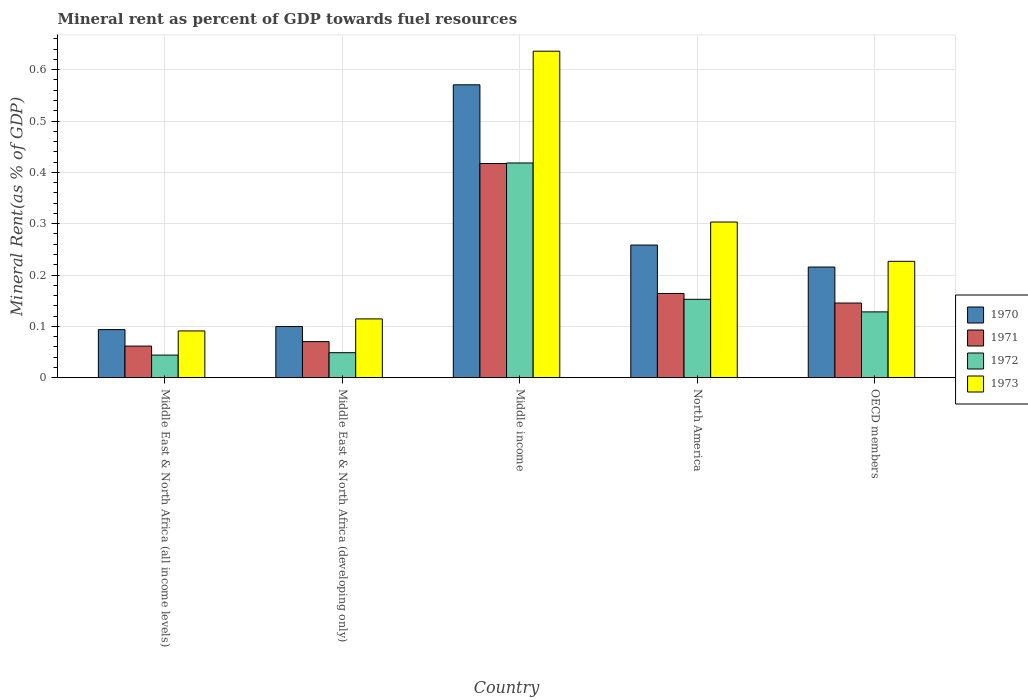How many different coloured bars are there?
Offer a terse response. 4. What is the label of the 3rd group of bars from the left?
Your answer should be compact. Middle income. What is the mineral rent in 1971 in OECD members?
Give a very brief answer. 0.15. Across all countries, what is the maximum mineral rent in 1972?
Offer a very short reply. 0.42. Across all countries, what is the minimum mineral rent in 1970?
Provide a short and direct response. 0.09. In which country was the mineral rent in 1971 maximum?
Offer a very short reply. Middle income. In which country was the mineral rent in 1973 minimum?
Your answer should be very brief. Middle East & North Africa (all income levels). What is the total mineral rent in 1972 in the graph?
Provide a succinct answer. 0.79. What is the difference between the mineral rent in 1971 in Middle East & North Africa (all income levels) and that in OECD members?
Your answer should be very brief. -0.08. What is the difference between the mineral rent in 1970 in Middle East & North Africa (developing only) and the mineral rent in 1972 in Middle East & North Africa (all income levels)?
Ensure brevity in your answer.  0.06. What is the average mineral rent in 1973 per country?
Provide a short and direct response. 0.27. What is the difference between the mineral rent of/in 1972 and mineral rent of/in 1970 in Middle East & North Africa (all income levels)?
Offer a very short reply. -0.05. What is the ratio of the mineral rent in 1973 in Middle East & North Africa (all income levels) to that in North America?
Keep it short and to the point. 0.3. Is the mineral rent in 1970 in Middle East & North Africa (developing only) less than that in OECD members?
Your answer should be very brief. Yes. What is the difference between the highest and the second highest mineral rent in 1970?
Offer a very short reply. 0.36. What is the difference between the highest and the lowest mineral rent in 1972?
Provide a short and direct response. 0.37. Is the sum of the mineral rent in 1971 in Middle income and North America greater than the maximum mineral rent in 1972 across all countries?
Your answer should be compact. Yes. What does the 4th bar from the left in OECD members represents?
Make the answer very short. 1973. What does the 3rd bar from the right in Middle East & North Africa (all income levels) represents?
Your answer should be very brief. 1971. How many bars are there?
Provide a succinct answer. 20. Are the values on the major ticks of Y-axis written in scientific E-notation?
Your response must be concise. No. Does the graph contain grids?
Offer a terse response. Yes. Where does the legend appear in the graph?
Give a very brief answer. Center right. How many legend labels are there?
Provide a succinct answer. 4. How are the legend labels stacked?
Ensure brevity in your answer.  Vertical. What is the title of the graph?
Provide a succinct answer. Mineral rent as percent of GDP towards fuel resources. What is the label or title of the Y-axis?
Provide a short and direct response. Mineral Rent(as % of GDP). What is the Mineral Rent(as % of GDP) in 1970 in Middle East & North Africa (all income levels)?
Offer a terse response. 0.09. What is the Mineral Rent(as % of GDP) of 1971 in Middle East & North Africa (all income levels)?
Your response must be concise. 0.06. What is the Mineral Rent(as % of GDP) in 1972 in Middle East & North Africa (all income levels)?
Your answer should be compact. 0.04. What is the Mineral Rent(as % of GDP) in 1973 in Middle East & North Africa (all income levels)?
Give a very brief answer. 0.09. What is the Mineral Rent(as % of GDP) of 1970 in Middle East & North Africa (developing only)?
Your answer should be very brief. 0.1. What is the Mineral Rent(as % of GDP) in 1971 in Middle East & North Africa (developing only)?
Your answer should be compact. 0.07. What is the Mineral Rent(as % of GDP) of 1972 in Middle East & North Africa (developing only)?
Offer a very short reply. 0.05. What is the Mineral Rent(as % of GDP) of 1973 in Middle East & North Africa (developing only)?
Provide a succinct answer. 0.11. What is the Mineral Rent(as % of GDP) in 1970 in Middle income?
Your answer should be compact. 0.57. What is the Mineral Rent(as % of GDP) of 1971 in Middle income?
Provide a short and direct response. 0.42. What is the Mineral Rent(as % of GDP) of 1972 in Middle income?
Offer a terse response. 0.42. What is the Mineral Rent(as % of GDP) of 1973 in Middle income?
Your answer should be very brief. 0.64. What is the Mineral Rent(as % of GDP) in 1970 in North America?
Offer a very short reply. 0.26. What is the Mineral Rent(as % of GDP) of 1971 in North America?
Offer a terse response. 0.16. What is the Mineral Rent(as % of GDP) of 1972 in North America?
Make the answer very short. 0.15. What is the Mineral Rent(as % of GDP) of 1973 in North America?
Offer a terse response. 0.3. What is the Mineral Rent(as % of GDP) in 1970 in OECD members?
Offer a very short reply. 0.22. What is the Mineral Rent(as % of GDP) of 1971 in OECD members?
Your response must be concise. 0.15. What is the Mineral Rent(as % of GDP) in 1972 in OECD members?
Offer a very short reply. 0.13. What is the Mineral Rent(as % of GDP) of 1973 in OECD members?
Ensure brevity in your answer.  0.23. Across all countries, what is the maximum Mineral Rent(as % of GDP) in 1970?
Your answer should be very brief. 0.57. Across all countries, what is the maximum Mineral Rent(as % of GDP) in 1971?
Your answer should be compact. 0.42. Across all countries, what is the maximum Mineral Rent(as % of GDP) in 1972?
Your response must be concise. 0.42. Across all countries, what is the maximum Mineral Rent(as % of GDP) in 1973?
Provide a succinct answer. 0.64. Across all countries, what is the minimum Mineral Rent(as % of GDP) in 1970?
Your response must be concise. 0.09. Across all countries, what is the minimum Mineral Rent(as % of GDP) in 1971?
Provide a short and direct response. 0.06. Across all countries, what is the minimum Mineral Rent(as % of GDP) in 1972?
Ensure brevity in your answer.  0.04. Across all countries, what is the minimum Mineral Rent(as % of GDP) of 1973?
Your answer should be compact. 0.09. What is the total Mineral Rent(as % of GDP) of 1970 in the graph?
Ensure brevity in your answer.  1.24. What is the total Mineral Rent(as % of GDP) of 1971 in the graph?
Your answer should be compact. 0.86. What is the total Mineral Rent(as % of GDP) of 1972 in the graph?
Offer a terse response. 0.79. What is the total Mineral Rent(as % of GDP) in 1973 in the graph?
Keep it short and to the point. 1.37. What is the difference between the Mineral Rent(as % of GDP) of 1970 in Middle East & North Africa (all income levels) and that in Middle East & North Africa (developing only)?
Make the answer very short. -0.01. What is the difference between the Mineral Rent(as % of GDP) of 1971 in Middle East & North Africa (all income levels) and that in Middle East & North Africa (developing only)?
Provide a short and direct response. -0.01. What is the difference between the Mineral Rent(as % of GDP) of 1972 in Middle East & North Africa (all income levels) and that in Middle East & North Africa (developing only)?
Offer a terse response. -0. What is the difference between the Mineral Rent(as % of GDP) of 1973 in Middle East & North Africa (all income levels) and that in Middle East & North Africa (developing only)?
Ensure brevity in your answer.  -0.02. What is the difference between the Mineral Rent(as % of GDP) of 1970 in Middle East & North Africa (all income levels) and that in Middle income?
Ensure brevity in your answer.  -0.48. What is the difference between the Mineral Rent(as % of GDP) in 1971 in Middle East & North Africa (all income levels) and that in Middle income?
Provide a short and direct response. -0.36. What is the difference between the Mineral Rent(as % of GDP) in 1972 in Middle East & North Africa (all income levels) and that in Middle income?
Your answer should be compact. -0.37. What is the difference between the Mineral Rent(as % of GDP) of 1973 in Middle East & North Africa (all income levels) and that in Middle income?
Make the answer very short. -0.55. What is the difference between the Mineral Rent(as % of GDP) in 1970 in Middle East & North Africa (all income levels) and that in North America?
Ensure brevity in your answer.  -0.16. What is the difference between the Mineral Rent(as % of GDP) of 1971 in Middle East & North Africa (all income levels) and that in North America?
Make the answer very short. -0.1. What is the difference between the Mineral Rent(as % of GDP) of 1972 in Middle East & North Africa (all income levels) and that in North America?
Offer a very short reply. -0.11. What is the difference between the Mineral Rent(as % of GDP) of 1973 in Middle East & North Africa (all income levels) and that in North America?
Offer a terse response. -0.21. What is the difference between the Mineral Rent(as % of GDP) of 1970 in Middle East & North Africa (all income levels) and that in OECD members?
Provide a short and direct response. -0.12. What is the difference between the Mineral Rent(as % of GDP) in 1971 in Middle East & North Africa (all income levels) and that in OECD members?
Offer a very short reply. -0.08. What is the difference between the Mineral Rent(as % of GDP) of 1972 in Middle East & North Africa (all income levels) and that in OECD members?
Your response must be concise. -0.08. What is the difference between the Mineral Rent(as % of GDP) in 1973 in Middle East & North Africa (all income levels) and that in OECD members?
Your response must be concise. -0.14. What is the difference between the Mineral Rent(as % of GDP) in 1970 in Middle East & North Africa (developing only) and that in Middle income?
Provide a succinct answer. -0.47. What is the difference between the Mineral Rent(as % of GDP) in 1971 in Middle East & North Africa (developing only) and that in Middle income?
Offer a terse response. -0.35. What is the difference between the Mineral Rent(as % of GDP) of 1972 in Middle East & North Africa (developing only) and that in Middle income?
Provide a succinct answer. -0.37. What is the difference between the Mineral Rent(as % of GDP) in 1973 in Middle East & North Africa (developing only) and that in Middle income?
Provide a short and direct response. -0.52. What is the difference between the Mineral Rent(as % of GDP) of 1970 in Middle East & North Africa (developing only) and that in North America?
Offer a very short reply. -0.16. What is the difference between the Mineral Rent(as % of GDP) in 1971 in Middle East & North Africa (developing only) and that in North America?
Provide a short and direct response. -0.09. What is the difference between the Mineral Rent(as % of GDP) in 1972 in Middle East & North Africa (developing only) and that in North America?
Give a very brief answer. -0.1. What is the difference between the Mineral Rent(as % of GDP) in 1973 in Middle East & North Africa (developing only) and that in North America?
Your response must be concise. -0.19. What is the difference between the Mineral Rent(as % of GDP) of 1970 in Middle East & North Africa (developing only) and that in OECD members?
Your answer should be compact. -0.12. What is the difference between the Mineral Rent(as % of GDP) in 1971 in Middle East & North Africa (developing only) and that in OECD members?
Provide a succinct answer. -0.08. What is the difference between the Mineral Rent(as % of GDP) in 1972 in Middle East & North Africa (developing only) and that in OECD members?
Your answer should be very brief. -0.08. What is the difference between the Mineral Rent(as % of GDP) of 1973 in Middle East & North Africa (developing only) and that in OECD members?
Offer a terse response. -0.11. What is the difference between the Mineral Rent(as % of GDP) in 1970 in Middle income and that in North America?
Offer a terse response. 0.31. What is the difference between the Mineral Rent(as % of GDP) in 1971 in Middle income and that in North America?
Provide a short and direct response. 0.25. What is the difference between the Mineral Rent(as % of GDP) of 1972 in Middle income and that in North America?
Your response must be concise. 0.27. What is the difference between the Mineral Rent(as % of GDP) of 1973 in Middle income and that in North America?
Offer a very short reply. 0.33. What is the difference between the Mineral Rent(as % of GDP) in 1970 in Middle income and that in OECD members?
Your answer should be compact. 0.35. What is the difference between the Mineral Rent(as % of GDP) in 1971 in Middle income and that in OECD members?
Offer a very short reply. 0.27. What is the difference between the Mineral Rent(as % of GDP) of 1972 in Middle income and that in OECD members?
Offer a terse response. 0.29. What is the difference between the Mineral Rent(as % of GDP) in 1973 in Middle income and that in OECD members?
Make the answer very short. 0.41. What is the difference between the Mineral Rent(as % of GDP) of 1970 in North America and that in OECD members?
Keep it short and to the point. 0.04. What is the difference between the Mineral Rent(as % of GDP) of 1971 in North America and that in OECD members?
Your answer should be very brief. 0.02. What is the difference between the Mineral Rent(as % of GDP) in 1972 in North America and that in OECD members?
Ensure brevity in your answer.  0.02. What is the difference between the Mineral Rent(as % of GDP) in 1973 in North America and that in OECD members?
Keep it short and to the point. 0.08. What is the difference between the Mineral Rent(as % of GDP) in 1970 in Middle East & North Africa (all income levels) and the Mineral Rent(as % of GDP) in 1971 in Middle East & North Africa (developing only)?
Ensure brevity in your answer.  0.02. What is the difference between the Mineral Rent(as % of GDP) of 1970 in Middle East & North Africa (all income levels) and the Mineral Rent(as % of GDP) of 1972 in Middle East & North Africa (developing only)?
Provide a succinct answer. 0.04. What is the difference between the Mineral Rent(as % of GDP) in 1970 in Middle East & North Africa (all income levels) and the Mineral Rent(as % of GDP) in 1973 in Middle East & North Africa (developing only)?
Provide a short and direct response. -0.02. What is the difference between the Mineral Rent(as % of GDP) in 1971 in Middle East & North Africa (all income levels) and the Mineral Rent(as % of GDP) in 1972 in Middle East & North Africa (developing only)?
Keep it short and to the point. 0.01. What is the difference between the Mineral Rent(as % of GDP) of 1971 in Middle East & North Africa (all income levels) and the Mineral Rent(as % of GDP) of 1973 in Middle East & North Africa (developing only)?
Provide a short and direct response. -0.05. What is the difference between the Mineral Rent(as % of GDP) of 1972 in Middle East & North Africa (all income levels) and the Mineral Rent(as % of GDP) of 1973 in Middle East & North Africa (developing only)?
Ensure brevity in your answer.  -0.07. What is the difference between the Mineral Rent(as % of GDP) of 1970 in Middle East & North Africa (all income levels) and the Mineral Rent(as % of GDP) of 1971 in Middle income?
Provide a short and direct response. -0.32. What is the difference between the Mineral Rent(as % of GDP) in 1970 in Middle East & North Africa (all income levels) and the Mineral Rent(as % of GDP) in 1972 in Middle income?
Make the answer very short. -0.32. What is the difference between the Mineral Rent(as % of GDP) in 1970 in Middle East & North Africa (all income levels) and the Mineral Rent(as % of GDP) in 1973 in Middle income?
Give a very brief answer. -0.54. What is the difference between the Mineral Rent(as % of GDP) in 1971 in Middle East & North Africa (all income levels) and the Mineral Rent(as % of GDP) in 1972 in Middle income?
Your answer should be compact. -0.36. What is the difference between the Mineral Rent(as % of GDP) of 1971 in Middle East & North Africa (all income levels) and the Mineral Rent(as % of GDP) of 1973 in Middle income?
Provide a short and direct response. -0.57. What is the difference between the Mineral Rent(as % of GDP) of 1972 in Middle East & North Africa (all income levels) and the Mineral Rent(as % of GDP) of 1973 in Middle income?
Provide a succinct answer. -0.59. What is the difference between the Mineral Rent(as % of GDP) of 1970 in Middle East & North Africa (all income levels) and the Mineral Rent(as % of GDP) of 1971 in North America?
Offer a terse response. -0.07. What is the difference between the Mineral Rent(as % of GDP) of 1970 in Middle East & North Africa (all income levels) and the Mineral Rent(as % of GDP) of 1972 in North America?
Your response must be concise. -0.06. What is the difference between the Mineral Rent(as % of GDP) in 1970 in Middle East & North Africa (all income levels) and the Mineral Rent(as % of GDP) in 1973 in North America?
Your response must be concise. -0.21. What is the difference between the Mineral Rent(as % of GDP) of 1971 in Middle East & North Africa (all income levels) and the Mineral Rent(as % of GDP) of 1972 in North America?
Keep it short and to the point. -0.09. What is the difference between the Mineral Rent(as % of GDP) in 1971 in Middle East & North Africa (all income levels) and the Mineral Rent(as % of GDP) in 1973 in North America?
Provide a short and direct response. -0.24. What is the difference between the Mineral Rent(as % of GDP) of 1972 in Middle East & North Africa (all income levels) and the Mineral Rent(as % of GDP) of 1973 in North America?
Provide a succinct answer. -0.26. What is the difference between the Mineral Rent(as % of GDP) of 1970 in Middle East & North Africa (all income levels) and the Mineral Rent(as % of GDP) of 1971 in OECD members?
Give a very brief answer. -0.05. What is the difference between the Mineral Rent(as % of GDP) in 1970 in Middle East & North Africa (all income levels) and the Mineral Rent(as % of GDP) in 1972 in OECD members?
Your answer should be very brief. -0.03. What is the difference between the Mineral Rent(as % of GDP) in 1970 in Middle East & North Africa (all income levels) and the Mineral Rent(as % of GDP) in 1973 in OECD members?
Make the answer very short. -0.13. What is the difference between the Mineral Rent(as % of GDP) of 1971 in Middle East & North Africa (all income levels) and the Mineral Rent(as % of GDP) of 1972 in OECD members?
Your answer should be very brief. -0.07. What is the difference between the Mineral Rent(as % of GDP) of 1971 in Middle East & North Africa (all income levels) and the Mineral Rent(as % of GDP) of 1973 in OECD members?
Ensure brevity in your answer.  -0.17. What is the difference between the Mineral Rent(as % of GDP) of 1972 in Middle East & North Africa (all income levels) and the Mineral Rent(as % of GDP) of 1973 in OECD members?
Offer a terse response. -0.18. What is the difference between the Mineral Rent(as % of GDP) of 1970 in Middle East & North Africa (developing only) and the Mineral Rent(as % of GDP) of 1971 in Middle income?
Provide a succinct answer. -0.32. What is the difference between the Mineral Rent(as % of GDP) of 1970 in Middle East & North Africa (developing only) and the Mineral Rent(as % of GDP) of 1972 in Middle income?
Offer a terse response. -0.32. What is the difference between the Mineral Rent(as % of GDP) in 1970 in Middle East & North Africa (developing only) and the Mineral Rent(as % of GDP) in 1973 in Middle income?
Make the answer very short. -0.54. What is the difference between the Mineral Rent(as % of GDP) of 1971 in Middle East & North Africa (developing only) and the Mineral Rent(as % of GDP) of 1972 in Middle income?
Make the answer very short. -0.35. What is the difference between the Mineral Rent(as % of GDP) in 1971 in Middle East & North Africa (developing only) and the Mineral Rent(as % of GDP) in 1973 in Middle income?
Ensure brevity in your answer.  -0.57. What is the difference between the Mineral Rent(as % of GDP) in 1972 in Middle East & North Africa (developing only) and the Mineral Rent(as % of GDP) in 1973 in Middle income?
Provide a succinct answer. -0.59. What is the difference between the Mineral Rent(as % of GDP) in 1970 in Middle East & North Africa (developing only) and the Mineral Rent(as % of GDP) in 1971 in North America?
Provide a succinct answer. -0.06. What is the difference between the Mineral Rent(as % of GDP) of 1970 in Middle East & North Africa (developing only) and the Mineral Rent(as % of GDP) of 1972 in North America?
Your answer should be compact. -0.05. What is the difference between the Mineral Rent(as % of GDP) in 1970 in Middle East & North Africa (developing only) and the Mineral Rent(as % of GDP) in 1973 in North America?
Provide a short and direct response. -0.2. What is the difference between the Mineral Rent(as % of GDP) in 1971 in Middle East & North Africa (developing only) and the Mineral Rent(as % of GDP) in 1972 in North America?
Offer a terse response. -0.08. What is the difference between the Mineral Rent(as % of GDP) of 1971 in Middle East & North Africa (developing only) and the Mineral Rent(as % of GDP) of 1973 in North America?
Offer a terse response. -0.23. What is the difference between the Mineral Rent(as % of GDP) in 1972 in Middle East & North Africa (developing only) and the Mineral Rent(as % of GDP) in 1973 in North America?
Offer a terse response. -0.25. What is the difference between the Mineral Rent(as % of GDP) in 1970 in Middle East & North Africa (developing only) and the Mineral Rent(as % of GDP) in 1971 in OECD members?
Provide a succinct answer. -0.05. What is the difference between the Mineral Rent(as % of GDP) in 1970 in Middle East & North Africa (developing only) and the Mineral Rent(as % of GDP) in 1972 in OECD members?
Give a very brief answer. -0.03. What is the difference between the Mineral Rent(as % of GDP) in 1970 in Middle East & North Africa (developing only) and the Mineral Rent(as % of GDP) in 1973 in OECD members?
Your answer should be compact. -0.13. What is the difference between the Mineral Rent(as % of GDP) of 1971 in Middle East & North Africa (developing only) and the Mineral Rent(as % of GDP) of 1972 in OECD members?
Keep it short and to the point. -0.06. What is the difference between the Mineral Rent(as % of GDP) in 1971 in Middle East & North Africa (developing only) and the Mineral Rent(as % of GDP) in 1973 in OECD members?
Keep it short and to the point. -0.16. What is the difference between the Mineral Rent(as % of GDP) of 1972 in Middle East & North Africa (developing only) and the Mineral Rent(as % of GDP) of 1973 in OECD members?
Keep it short and to the point. -0.18. What is the difference between the Mineral Rent(as % of GDP) in 1970 in Middle income and the Mineral Rent(as % of GDP) in 1971 in North America?
Give a very brief answer. 0.41. What is the difference between the Mineral Rent(as % of GDP) of 1970 in Middle income and the Mineral Rent(as % of GDP) of 1972 in North America?
Offer a terse response. 0.42. What is the difference between the Mineral Rent(as % of GDP) of 1970 in Middle income and the Mineral Rent(as % of GDP) of 1973 in North America?
Your answer should be very brief. 0.27. What is the difference between the Mineral Rent(as % of GDP) in 1971 in Middle income and the Mineral Rent(as % of GDP) in 1972 in North America?
Ensure brevity in your answer.  0.26. What is the difference between the Mineral Rent(as % of GDP) in 1971 in Middle income and the Mineral Rent(as % of GDP) in 1973 in North America?
Keep it short and to the point. 0.11. What is the difference between the Mineral Rent(as % of GDP) in 1972 in Middle income and the Mineral Rent(as % of GDP) in 1973 in North America?
Your response must be concise. 0.12. What is the difference between the Mineral Rent(as % of GDP) of 1970 in Middle income and the Mineral Rent(as % of GDP) of 1971 in OECD members?
Your response must be concise. 0.43. What is the difference between the Mineral Rent(as % of GDP) in 1970 in Middle income and the Mineral Rent(as % of GDP) in 1972 in OECD members?
Your answer should be compact. 0.44. What is the difference between the Mineral Rent(as % of GDP) in 1970 in Middle income and the Mineral Rent(as % of GDP) in 1973 in OECD members?
Keep it short and to the point. 0.34. What is the difference between the Mineral Rent(as % of GDP) in 1971 in Middle income and the Mineral Rent(as % of GDP) in 1972 in OECD members?
Your response must be concise. 0.29. What is the difference between the Mineral Rent(as % of GDP) in 1971 in Middle income and the Mineral Rent(as % of GDP) in 1973 in OECD members?
Provide a succinct answer. 0.19. What is the difference between the Mineral Rent(as % of GDP) in 1972 in Middle income and the Mineral Rent(as % of GDP) in 1973 in OECD members?
Provide a succinct answer. 0.19. What is the difference between the Mineral Rent(as % of GDP) in 1970 in North America and the Mineral Rent(as % of GDP) in 1971 in OECD members?
Offer a terse response. 0.11. What is the difference between the Mineral Rent(as % of GDP) in 1970 in North America and the Mineral Rent(as % of GDP) in 1972 in OECD members?
Offer a very short reply. 0.13. What is the difference between the Mineral Rent(as % of GDP) in 1970 in North America and the Mineral Rent(as % of GDP) in 1973 in OECD members?
Offer a very short reply. 0.03. What is the difference between the Mineral Rent(as % of GDP) in 1971 in North America and the Mineral Rent(as % of GDP) in 1972 in OECD members?
Offer a terse response. 0.04. What is the difference between the Mineral Rent(as % of GDP) in 1971 in North America and the Mineral Rent(as % of GDP) in 1973 in OECD members?
Your answer should be very brief. -0.06. What is the difference between the Mineral Rent(as % of GDP) in 1972 in North America and the Mineral Rent(as % of GDP) in 1973 in OECD members?
Make the answer very short. -0.07. What is the average Mineral Rent(as % of GDP) of 1970 per country?
Your answer should be compact. 0.25. What is the average Mineral Rent(as % of GDP) in 1971 per country?
Offer a terse response. 0.17. What is the average Mineral Rent(as % of GDP) of 1972 per country?
Your response must be concise. 0.16. What is the average Mineral Rent(as % of GDP) in 1973 per country?
Keep it short and to the point. 0.27. What is the difference between the Mineral Rent(as % of GDP) of 1970 and Mineral Rent(as % of GDP) of 1971 in Middle East & North Africa (all income levels)?
Offer a terse response. 0.03. What is the difference between the Mineral Rent(as % of GDP) of 1970 and Mineral Rent(as % of GDP) of 1972 in Middle East & North Africa (all income levels)?
Provide a short and direct response. 0.05. What is the difference between the Mineral Rent(as % of GDP) in 1970 and Mineral Rent(as % of GDP) in 1973 in Middle East & North Africa (all income levels)?
Provide a succinct answer. 0. What is the difference between the Mineral Rent(as % of GDP) of 1971 and Mineral Rent(as % of GDP) of 1972 in Middle East & North Africa (all income levels)?
Make the answer very short. 0.02. What is the difference between the Mineral Rent(as % of GDP) of 1971 and Mineral Rent(as % of GDP) of 1973 in Middle East & North Africa (all income levels)?
Give a very brief answer. -0.03. What is the difference between the Mineral Rent(as % of GDP) of 1972 and Mineral Rent(as % of GDP) of 1973 in Middle East & North Africa (all income levels)?
Your answer should be compact. -0.05. What is the difference between the Mineral Rent(as % of GDP) of 1970 and Mineral Rent(as % of GDP) of 1971 in Middle East & North Africa (developing only)?
Ensure brevity in your answer.  0.03. What is the difference between the Mineral Rent(as % of GDP) of 1970 and Mineral Rent(as % of GDP) of 1972 in Middle East & North Africa (developing only)?
Keep it short and to the point. 0.05. What is the difference between the Mineral Rent(as % of GDP) in 1970 and Mineral Rent(as % of GDP) in 1973 in Middle East & North Africa (developing only)?
Ensure brevity in your answer.  -0.01. What is the difference between the Mineral Rent(as % of GDP) in 1971 and Mineral Rent(as % of GDP) in 1972 in Middle East & North Africa (developing only)?
Your answer should be very brief. 0.02. What is the difference between the Mineral Rent(as % of GDP) in 1971 and Mineral Rent(as % of GDP) in 1973 in Middle East & North Africa (developing only)?
Your response must be concise. -0.04. What is the difference between the Mineral Rent(as % of GDP) of 1972 and Mineral Rent(as % of GDP) of 1973 in Middle East & North Africa (developing only)?
Your answer should be very brief. -0.07. What is the difference between the Mineral Rent(as % of GDP) of 1970 and Mineral Rent(as % of GDP) of 1971 in Middle income?
Offer a terse response. 0.15. What is the difference between the Mineral Rent(as % of GDP) in 1970 and Mineral Rent(as % of GDP) in 1972 in Middle income?
Offer a very short reply. 0.15. What is the difference between the Mineral Rent(as % of GDP) in 1970 and Mineral Rent(as % of GDP) in 1973 in Middle income?
Give a very brief answer. -0.07. What is the difference between the Mineral Rent(as % of GDP) of 1971 and Mineral Rent(as % of GDP) of 1972 in Middle income?
Ensure brevity in your answer.  -0. What is the difference between the Mineral Rent(as % of GDP) of 1971 and Mineral Rent(as % of GDP) of 1973 in Middle income?
Ensure brevity in your answer.  -0.22. What is the difference between the Mineral Rent(as % of GDP) of 1972 and Mineral Rent(as % of GDP) of 1973 in Middle income?
Your answer should be compact. -0.22. What is the difference between the Mineral Rent(as % of GDP) of 1970 and Mineral Rent(as % of GDP) of 1971 in North America?
Offer a very short reply. 0.09. What is the difference between the Mineral Rent(as % of GDP) in 1970 and Mineral Rent(as % of GDP) in 1972 in North America?
Your answer should be compact. 0.11. What is the difference between the Mineral Rent(as % of GDP) of 1970 and Mineral Rent(as % of GDP) of 1973 in North America?
Offer a very short reply. -0.04. What is the difference between the Mineral Rent(as % of GDP) in 1971 and Mineral Rent(as % of GDP) in 1972 in North America?
Keep it short and to the point. 0.01. What is the difference between the Mineral Rent(as % of GDP) in 1971 and Mineral Rent(as % of GDP) in 1973 in North America?
Your answer should be very brief. -0.14. What is the difference between the Mineral Rent(as % of GDP) in 1972 and Mineral Rent(as % of GDP) in 1973 in North America?
Give a very brief answer. -0.15. What is the difference between the Mineral Rent(as % of GDP) of 1970 and Mineral Rent(as % of GDP) of 1971 in OECD members?
Make the answer very short. 0.07. What is the difference between the Mineral Rent(as % of GDP) of 1970 and Mineral Rent(as % of GDP) of 1972 in OECD members?
Ensure brevity in your answer.  0.09. What is the difference between the Mineral Rent(as % of GDP) of 1970 and Mineral Rent(as % of GDP) of 1973 in OECD members?
Your answer should be compact. -0.01. What is the difference between the Mineral Rent(as % of GDP) of 1971 and Mineral Rent(as % of GDP) of 1972 in OECD members?
Provide a short and direct response. 0.02. What is the difference between the Mineral Rent(as % of GDP) in 1971 and Mineral Rent(as % of GDP) in 1973 in OECD members?
Provide a short and direct response. -0.08. What is the difference between the Mineral Rent(as % of GDP) of 1972 and Mineral Rent(as % of GDP) of 1973 in OECD members?
Provide a short and direct response. -0.1. What is the ratio of the Mineral Rent(as % of GDP) in 1970 in Middle East & North Africa (all income levels) to that in Middle East & North Africa (developing only)?
Ensure brevity in your answer.  0.94. What is the ratio of the Mineral Rent(as % of GDP) in 1971 in Middle East & North Africa (all income levels) to that in Middle East & North Africa (developing only)?
Your answer should be very brief. 0.88. What is the ratio of the Mineral Rent(as % of GDP) in 1972 in Middle East & North Africa (all income levels) to that in Middle East & North Africa (developing only)?
Your answer should be very brief. 0.9. What is the ratio of the Mineral Rent(as % of GDP) in 1973 in Middle East & North Africa (all income levels) to that in Middle East & North Africa (developing only)?
Your answer should be very brief. 0.8. What is the ratio of the Mineral Rent(as % of GDP) in 1970 in Middle East & North Africa (all income levels) to that in Middle income?
Your answer should be very brief. 0.16. What is the ratio of the Mineral Rent(as % of GDP) of 1971 in Middle East & North Africa (all income levels) to that in Middle income?
Give a very brief answer. 0.15. What is the ratio of the Mineral Rent(as % of GDP) of 1972 in Middle East & North Africa (all income levels) to that in Middle income?
Offer a very short reply. 0.11. What is the ratio of the Mineral Rent(as % of GDP) in 1973 in Middle East & North Africa (all income levels) to that in Middle income?
Make the answer very short. 0.14. What is the ratio of the Mineral Rent(as % of GDP) in 1970 in Middle East & North Africa (all income levels) to that in North America?
Make the answer very short. 0.36. What is the ratio of the Mineral Rent(as % of GDP) in 1971 in Middle East & North Africa (all income levels) to that in North America?
Your response must be concise. 0.38. What is the ratio of the Mineral Rent(as % of GDP) of 1972 in Middle East & North Africa (all income levels) to that in North America?
Provide a short and direct response. 0.29. What is the ratio of the Mineral Rent(as % of GDP) in 1973 in Middle East & North Africa (all income levels) to that in North America?
Your answer should be very brief. 0.3. What is the ratio of the Mineral Rent(as % of GDP) of 1970 in Middle East & North Africa (all income levels) to that in OECD members?
Offer a terse response. 0.43. What is the ratio of the Mineral Rent(as % of GDP) of 1971 in Middle East & North Africa (all income levels) to that in OECD members?
Provide a short and direct response. 0.42. What is the ratio of the Mineral Rent(as % of GDP) in 1972 in Middle East & North Africa (all income levels) to that in OECD members?
Provide a short and direct response. 0.34. What is the ratio of the Mineral Rent(as % of GDP) of 1973 in Middle East & North Africa (all income levels) to that in OECD members?
Your answer should be very brief. 0.4. What is the ratio of the Mineral Rent(as % of GDP) of 1970 in Middle East & North Africa (developing only) to that in Middle income?
Provide a short and direct response. 0.17. What is the ratio of the Mineral Rent(as % of GDP) of 1971 in Middle East & North Africa (developing only) to that in Middle income?
Your response must be concise. 0.17. What is the ratio of the Mineral Rent(as % of GDP) in 1972 in Middle East & North Africa (developing only) to that in Middle income?
Your response must be concise. 0.12. What is the ratio of the Mineral Rent(as % of GDP) of 1973 in Middle East & North Africa (developing only) to that in Middle income?
Provide a succinct answer. 0.18. What is the ratio of the Mineral Rent(as % of GDP) in 1970 in Middle East & North Africa (developing only) to that in North America?
Your answer should be very brief. 0.39. What is the ratio of the Mineral Rent(as % of GDP) in 1971 in Middle East & North Africa (developing only) to that in North America?
Offer a very short reply. 0.43. What is the ratio of the Mineral Rent(as % of GDP) in 1972 in Middle East & North Africa (developing only) to that in North America?
Ensure brevity in your answer.  0.32. What is the ratio of the Mineral Rent(as % of GDP) of 1973 in Middle East & North Africa (developing only) to that in North America?
Your response must be concise. 0.38. What is the ratio of the Mineral Rent(as % of GDP) of 1970 in Middle East & North Africa (developing only) to that in OECD members?
Give a very brief answer. 0.46. What is the ratio of the Mineral Rent(as % of GDP) of 1971 in Middle East & North Africa (developing only) to that in OECD members?
Keep it short and to the point. 0.48. What is the ratio of the Mineral Rent(as % of GDP) in 1972 in Middle East & North Africa (developing only) to that in OECD members?
Offer a very short reply. 0.38. What is the ratio of the Mineral Rent(as % of GDP) in 1973 in Middle East & North Africa (developing only) to that in OECD members?
Your answer should be very brief. 0.51. What is the ratio of the Mineral Rent(as % of GDP) of 1970 in Middle income to that in North America?
Give a very brief answer. 2.21. What is the ratio of the Mineral Rent(as % of GDP) of 1971 in Middle income to that in North America?
Make the answer very short. 2.54. What is the ratio of the Mineral Rent(as % of GDP) of 1972 in Middle income to that in North America?
Ensure brevity in your answer.  2.74. What is the ratio of the Mineral Rent(as % of GDP) of 1973 in Middle income to that in North America?
Offer a very short reply. 2.1. What is the ratio of the Mineral Rent(as % of GDP) of 1970 in Middle income to that in OECD members?
Keep it short and to the point. 2.65. What is the ratio of the Mineral Rent(as % of GDP) of 1971 in Middle income to that in OECD members?
Offer a terse response. 2.87. What is the ratio of the Mineral Rent(as % of GDP) in 1972 in Middle income to that in OECD members?
Offer a terse response. 3.26. What is the ratio of the Mineral Rent(as % of GDP) of 1973 in Middle income to that in OECD members?
Provide a succinct answer. 2.81. What is the ratio of the Mineral Rent(as % of GDP) of 1970 in North America to that in OECD members?
Provide a short and direct response. 1.2. What is the ratio of the Mineral Rent(as % of GDP) in 1971 in North America to that in OECD members?
Give a very brief answer. 1.13. What is the ratio of the Mineral Rent(as % of GDP) of 1972 in North America to that in OECD members?
Keep it short and to the point. 1.19. What is the ratio of the Mineral Rent(as % of GDP) of 1973 in North America to that in OECD members?
Your response must be concise. 1.34. What is the difference between the highest and the second highest Mineral Rent(as % of GDP) in 1970?
Make the answer very short. 0.31. What is the difference between the highest and the second highest Mineral Rent(as % of GDP) in 1971?
Keep it short and to the point. 0.25. What is the difference between the highest and the second highest Mineral Rent(as % of GDP) in 1972?
Keep it short and to the point. 0.27. What is the difference between the highest and the second highest Mineral Rent(as % of GDP) of 1973?
Provide a succinct answer. 0.33. What is the difference between the highest and the lowest Mineral Rent(as % of GDP) in 1970?
Give a very brief answer. 0.48. What is the difference between the highest and the lowest Mineral Rent(as % of GDP) in 1971?
Give a very brief answer. 0.36. What is the difference between the highest and the lowest Mineral Rent(as % of GDP) of 1972?
Make the answer very short. 0.37. What is the difference between the highest and the lowest Mineral Rent(as % of GDP) in 1973?
Provide a short and direct response. 0.55. 